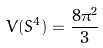Convert formula to latex. <formula><loc_0><loc_0><loc_500><loc_500>V ( S ^ { 4 } ) = \frac { 8 \pi ^ { 2 } } { 3 }</formula> 